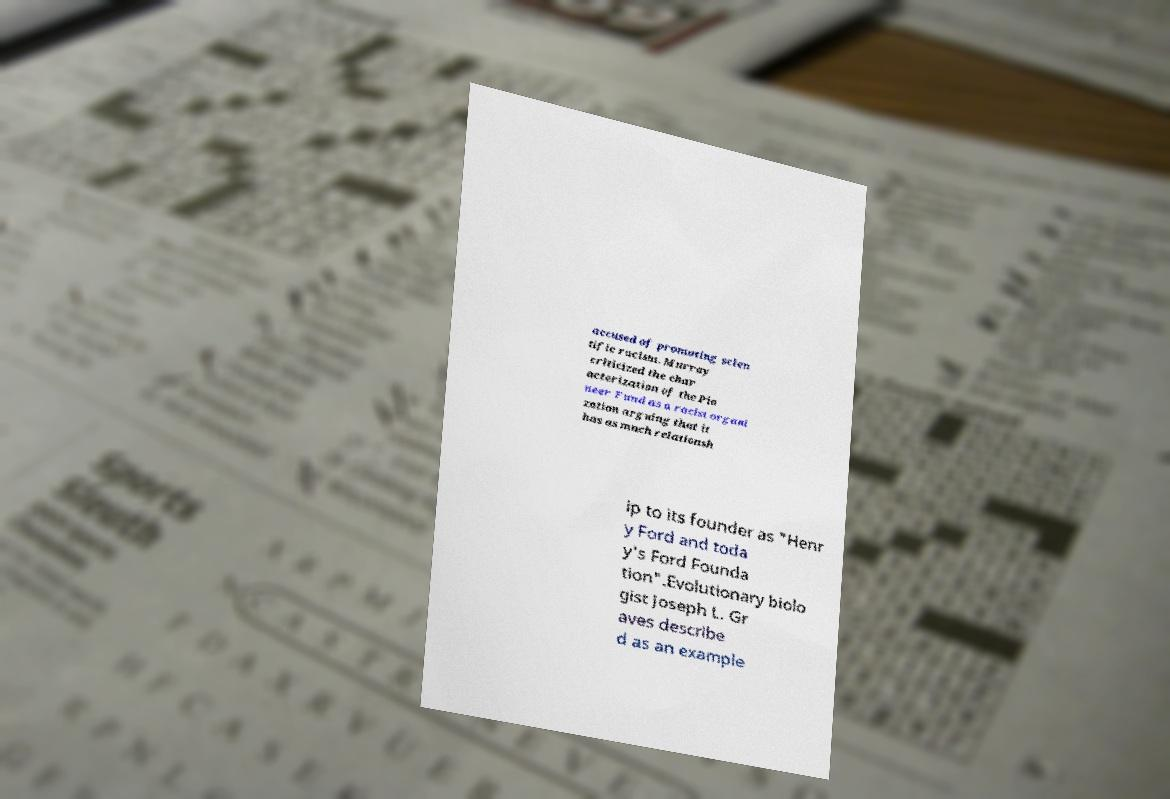Please read and relay the text visible in this image. What does it say? accused of promoting scien tific racism. Murray criticized the char acterization of the Pio neer Fund as a racist organi zation arguing that it has as much relationsh ip to its founder as "Henr y Ford and toda y's Ford Founda tion".Evolutionary biolo gist Joseph L. Gr aves describe d as an example 